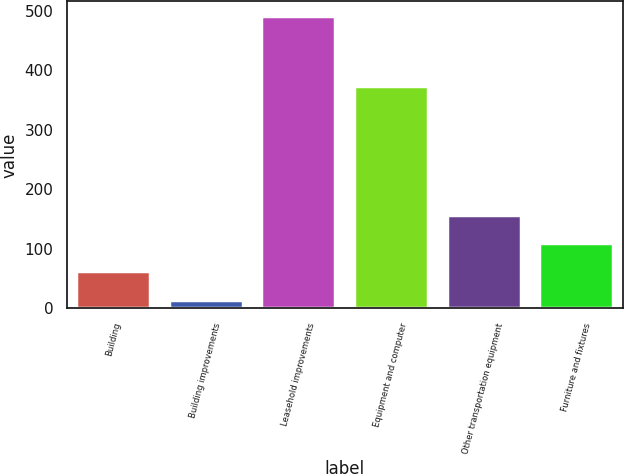Convert chart. <chart><loc_0><loc_0><loc_500><loc_500><bar_chart><fcel>Building<fcel>Building improvements<fcel>Leasehold improvements<fcel>Equipment and computer<fcel>Other transportation equipment<fcel>Furniture and fixtures<nl><fcel>62.6<fcel>15<fcel>491<fcel>374<fcel>157.8<fcel>110.2<nl></chart> 